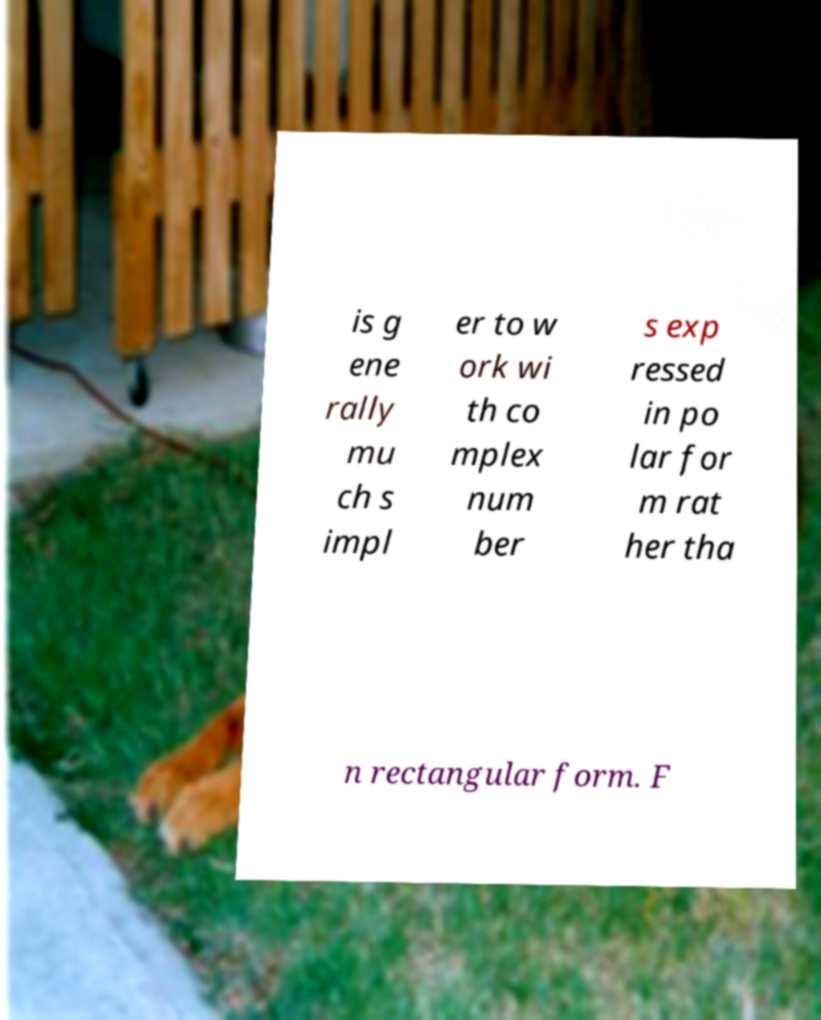Please read and relay the text visible in this image. What does it say? is g ene rally mu ch s impl er to w ork wi th co mplex num ber s exp ressed in po lar for m rat her tha n rectangular form. F 